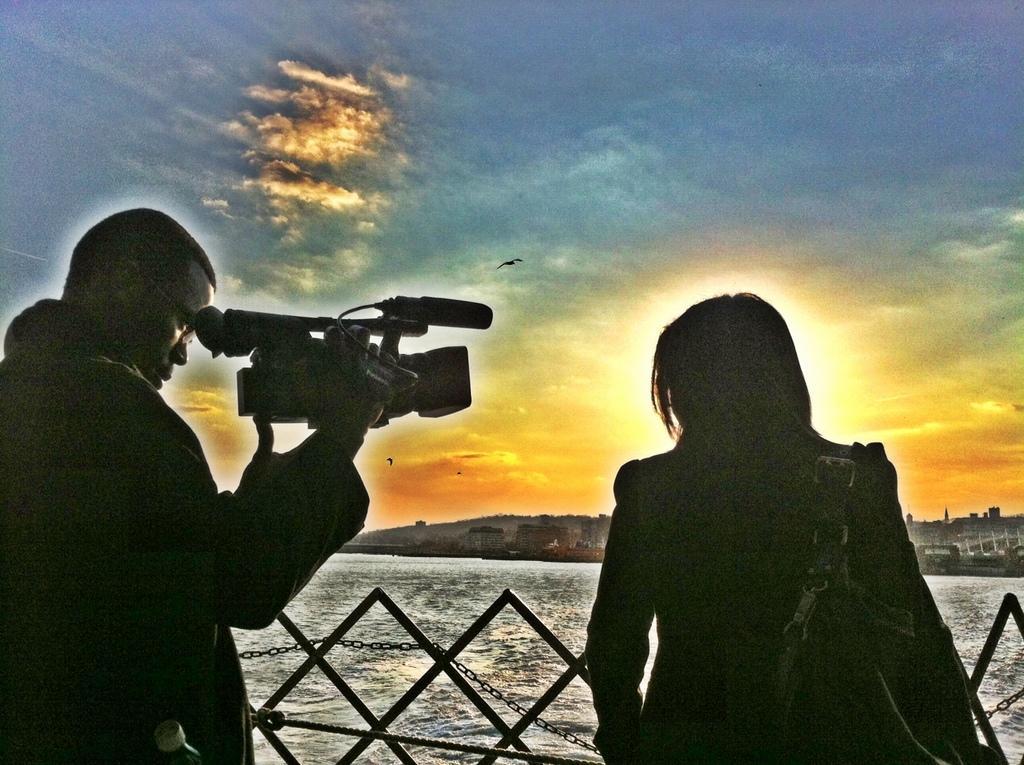In one or two sentences, can you explain what this image depicts? In the image we can see there are people standing and in front of them there is water. A man is holding video camera in his hand and a woman is carrying bag. There are birds flying in the sky. 